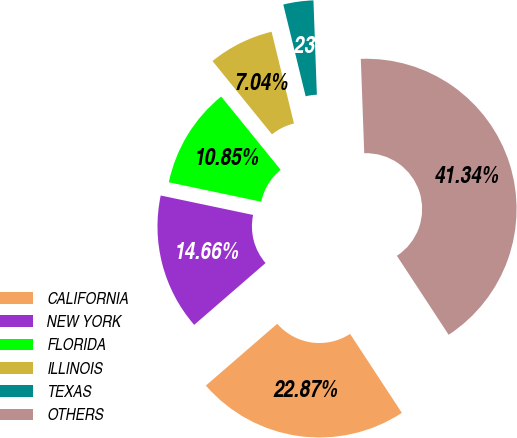<chart> <loc_0><loc_0><loc_500><loc_500><pie_chart><fcel>CALIFORNIA<fcel>NEW YORK<fcel>FLORIDA<fcel>ILLINOIS<fcel>TEXAS<fcel>OTHERS<nl><fcel>22.87%<fcel>14.66%<fcel>10.85%<fcel>7.04%<fcel>3.23%<fcel>41.34%<nl></chart> 